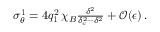<formula> <loc_0><loc_0><loc_500><loc_500>\begin{array} { r } { \sigma _ { \theta } ^ { 1 } = 4 q _ { 1 } ^ { 2 } \, \chi _ { B } \frac { \delta ^ { 2 } } { \delta _ { c } ^ { 2 } - \delta ^ { 2 } } + \mathcal { O } ( \epsilon ) \, . } \end{array}</formula> 